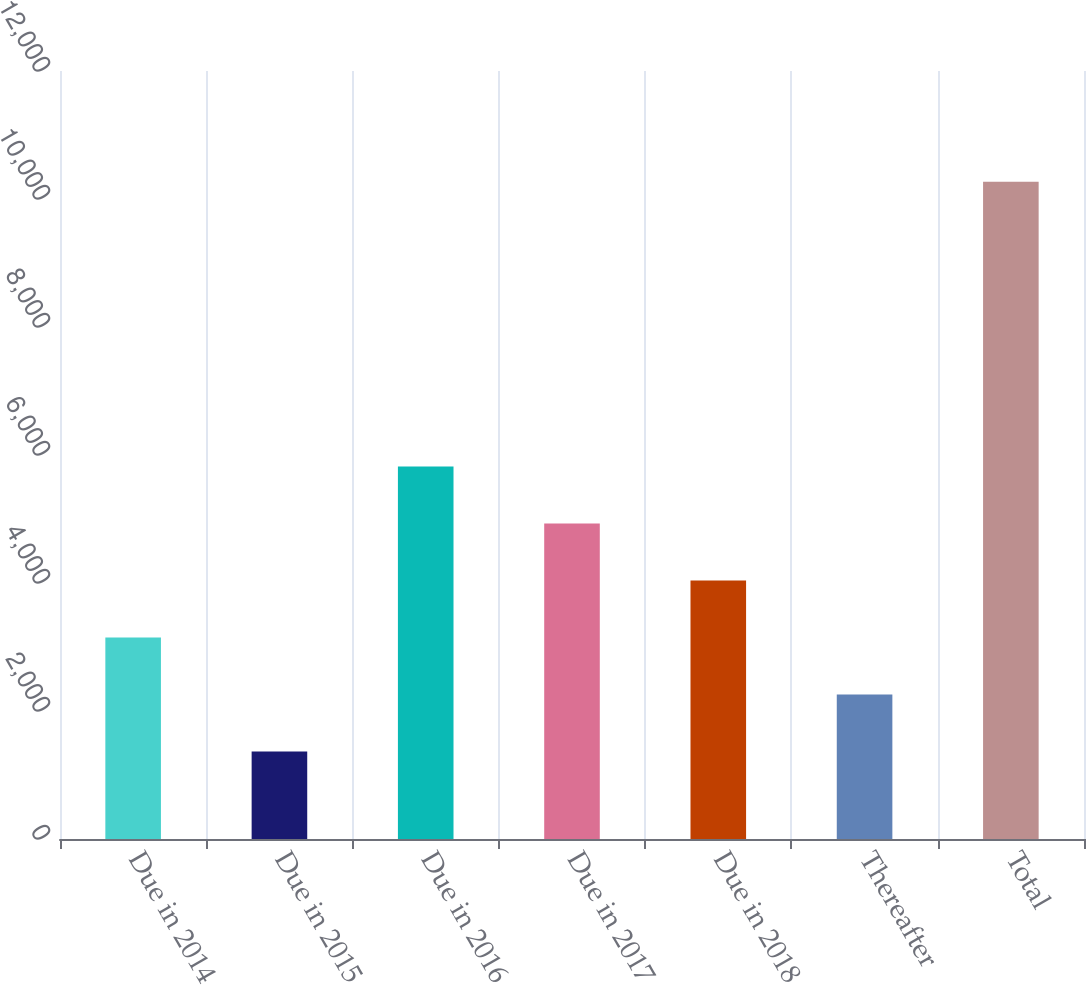<chart> <loc_0><loc_0><loc_500><loc_500><bar_chart><fcel>Due in 2014<fcel>Due in 2015<fcel>Due in 2016<fcel>Due in 2017<fcel>Due in 2018<fcel>Thereafter<fcel>Total<nl><fcel>3148.4<fcel>1368<fcel>5819<fcel>4928.8<fcel>4038.6<fcel>2258.2<fcel>10270<nl></chart> 